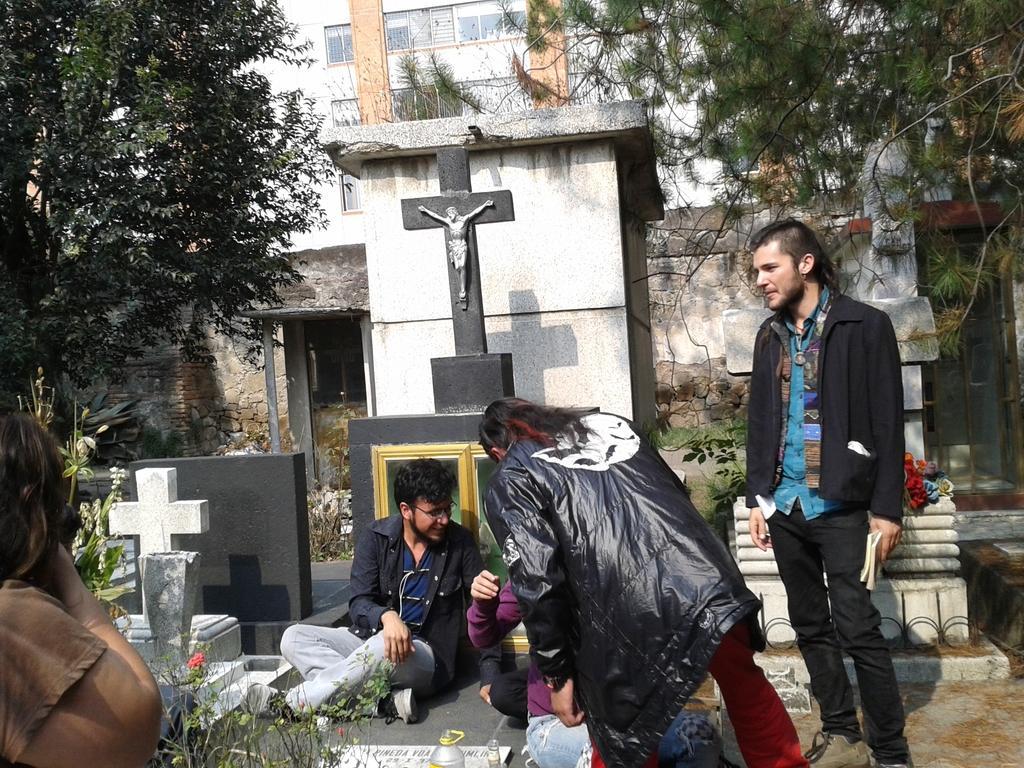In one or two sentences, can you explain what this image depicts? This picture describes about group of people, few are seated and few are standing, in front of them we can find few bottles and plants, in the background we can see graves, trees and a building. 